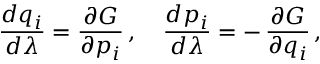<formula> <loc_0><loc_0><loc_500><loc_500>{ \frac { d q _ { i } } { d \lambda } } = { \frac { \partial G } { \partial p _ { i } } } \, , \quad \frac { d p _ { i } } { d \lambda } = - \, { \frac { \partial G } { \partial q _ { i } } } \, ,</formula> 